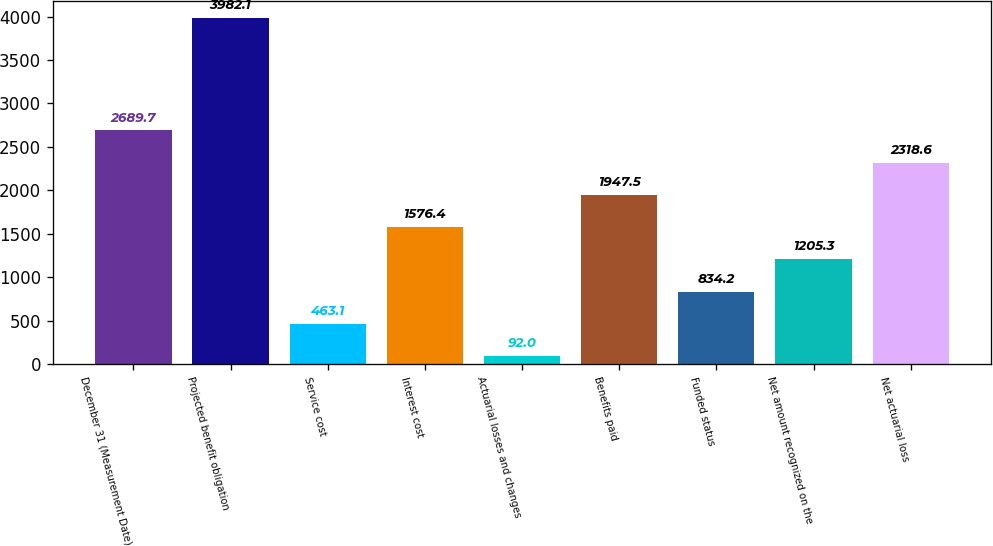<chart> <loc_0><loc_0><loc_500><loc_500><bar_chart><fcel>December 31 (Measurement Date)<fcel>Projected benefit obligation<fcel>Service cost<fcel>Interest cost<fcel>Actuarial losses and changes<fcel>Benefits paid<fcel>Funded status<fcel>Net amount recognized on the<fcel>Net actuarial loss<nl><fcel>2689.7<fcel>3982.1<fcel>463.1<fcel>1576.4<fcel>92<fcel>1947.5<fcel>834.2<fcel>1205.3<fcel>2318.6<nl></chart> 